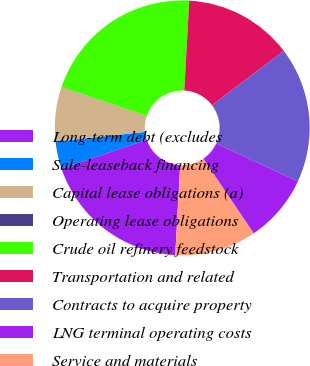<chart> <loc_0><loc_0><loc_500><loc_500><pie_chart><fcel>Long-term debt (excludes<fcel>Sale-leaseback financing<fcel>Capital lease obligations (a)<fcel>Operating lease obligations<fcel>Crude oil refinery feedstock<fcel>Transportation and related<fcel>Contracts to acquire property<fcel>LNG terminal operating costs<fcel>Service and materials<nl><fcel>18.95%<fcel>3.46%<fcel>6.91%<fcel>0.02%<fcel>20.67%<fcel>13.79%<fcel>17.23%<fcel>8.63%<fcel>10.35%<nl></chart> 